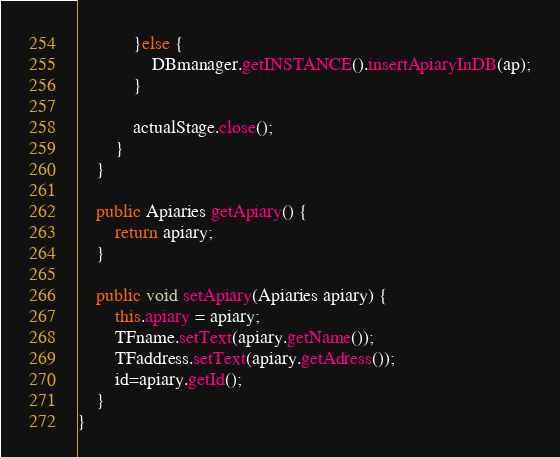<code> <loc_0><loc_0><loc_500><loc_500><_Java_>            }else {
                DBmanager.getINSTANCE().insertApiaryInDB(ap);
            }

            actualStage.close();
        }
    }

    public Apiaries getApiary() {
        return apiary;
    }

    public void setApiary(Apiaries apiary) {
        this.apiary = apiary;
        TFname.setText(apiary.getName());
        TFaddress.setText(apiary.getAdress());
        id=apiary.getId();
    }
}
</code> 